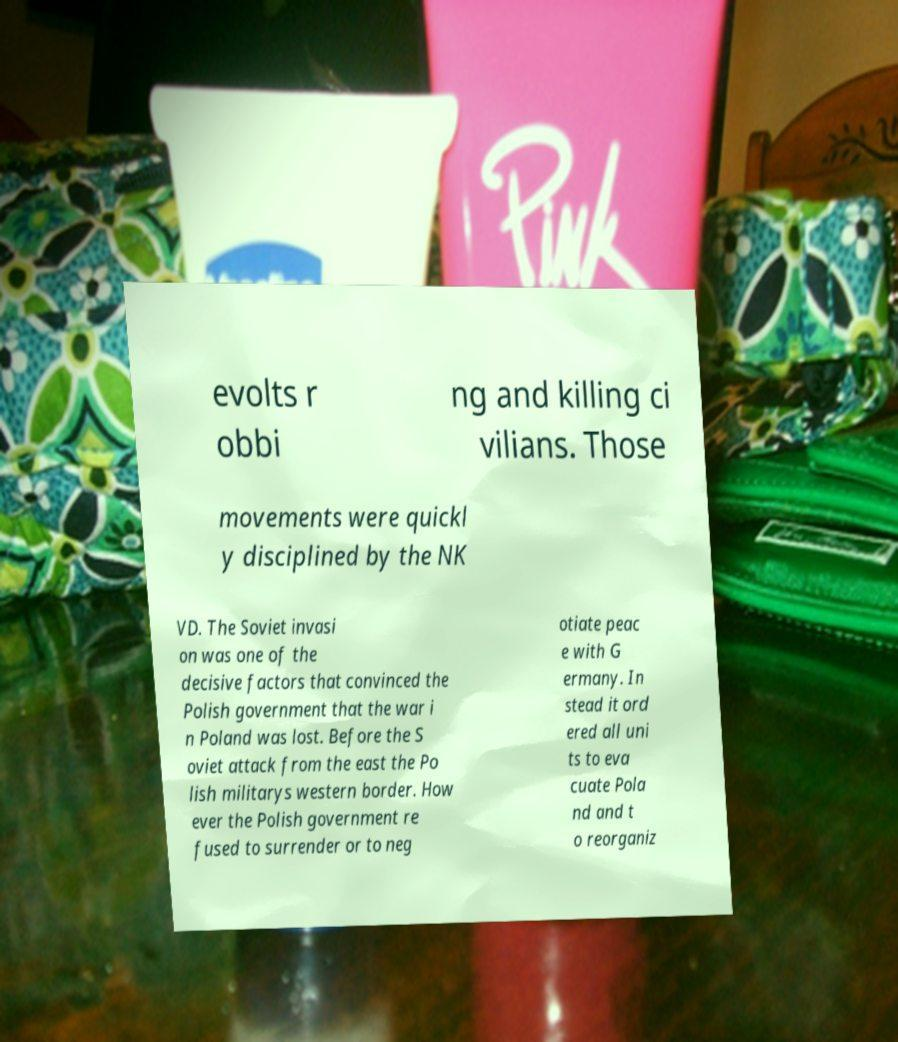Can you accurately transcribe the text from the provided image for me? evolts r obbi ng and killing ci vilians. Those movements were quickl y disciplined by the NK VD. The Soviet invasi on was one of the decisive factors that convinced the Polish government that the war i n Poland was lost. Before the S oviet attack from the east the Po lish militarys western border. How ever the Polish government re fused to surrender or to neg otiate peac e with G ermany. In stead it ord ered all uni ts to eva cuate Pola nd and t o reorganiz 